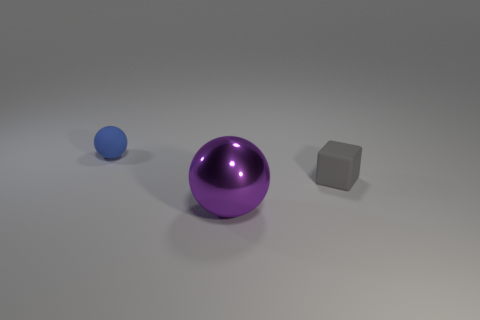Add 1 small matte balls. How many objects exist? 4 Subtract all purple spheres. How many spheres are left? 1 Add 1 large metal objects. How many large metal objects exist? 2 Subtract 0 gray spheres. How many objects are left? 3 Subtract all balls. How many objects are left? 1 Subtract 1 cubes. How many cubes are left? 0 Subtract all cyan blocks. Subtract all brown spheres. How many blocks are left? 1 Subtract all yellow cubes. How many brown balls are left? 0 Subtract all cubes. Subtract all purple metal things. How many objects are left? 1 Add 3 tiny objects. How many tiny objects are left? 5 